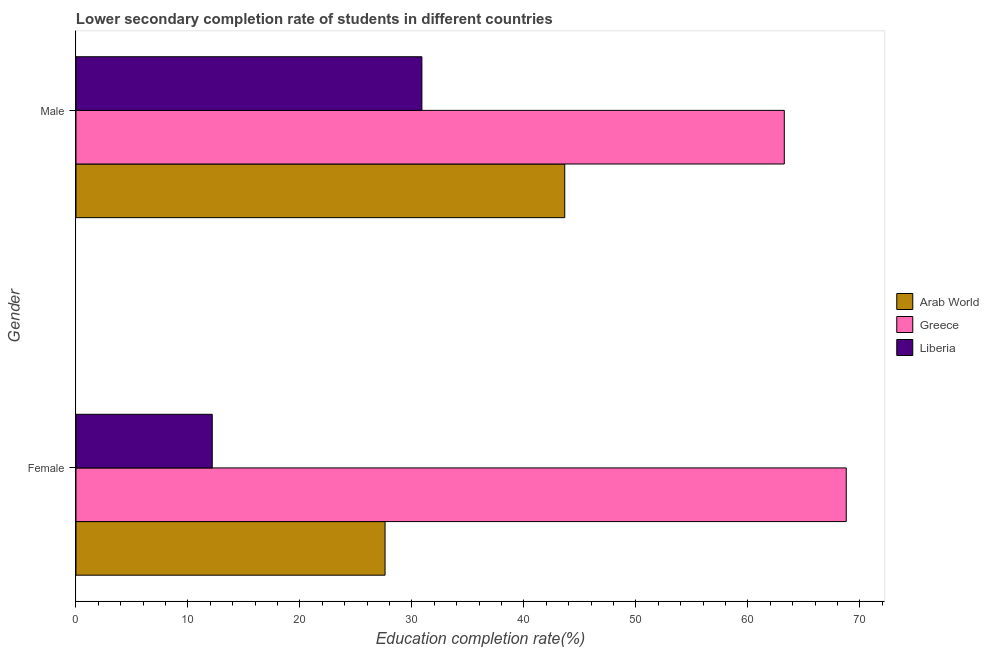Are the number of bars per tick equal to the number of legend labels?
Keep it short and to the point. Yes. What is the education completion rate of female students in Arab World?
Offer a terse response. 27.6. Across all countries, what is the maximum education completion rate of male students?
Your response must be concise. 63.25. Across all countries, what is the minimum education completion rate of male students?
Ensure brevity in your answer.  30.89. In which country was the education completion rate of female students minimum?
Offer a very short reply. Liberia. What is the total education completion rate of male students in the graph?
Offer a very short reply. 137.79. What is the difference between the education completion rate of male students in Arab World and that in Liberia?
Provide a succinct answer. 12.76. What is the difference between the education completion rate of female students in Liberia and the education completion rate of male students in Greece?
Ensure brevity in your answer.  -51.08. What is the average education completion rate of male students per country?
Your answer should be compact. 45.93. What is the difference between the education completion rate of male students and education completion rate of female students in Greece?
Your answer should be very brief. -5.53. In how many countries, is the education completion rate of female students greater than 14 %?
Ensure brevity in your answer.  2. What is the ratio of the education completion rate of male students in Greece to that in Arab World?
Your answer should be compact. 1.45. Is the education completion rate of male students in Arab World less than that in Liberia?
Your answer should be compact. No. In how many countries, is the education completion rate of male students greater than the average education completion rate of male students taken over all countries?
Keep it short and to the point. 1. What does the 1st bar from the top in Female represents?
Provide a succinct answer. Liberia. What does the 2nd bar from the bottom in Male represents?
Your answer should be very brief. Greece. Are all the bars in the graph horizontal?
Give a very brief answer. Yes. What is the difference between two consecutive major ticks on the X-axis?
Your answer should be very brief. 10. Are the values on the major ticks of X-axis written in scientific E-notation?
Your response must be concise. No. How many legend labels are there?
Ensure brevity in your answer.  3. What is the title of the graph?
Keep it short and to the point. Lower secondary completion rate of students in different countries. Does "Turks and Caicos Islands" appear as one of the legend labels in the graph?
Provide a short and direct response. No. What is the label or title of the X-axis?
Offer a very short reply. Education completion rate(%). What is the Education completion rate(%) in Arab World in Female?
Make the answer very short. 27.6. What is the Education completion rate(%) in Greece in Female?
Provide a succinct answer. 68.78. What is the Education completion rate(%) in Liberia in Female?
Your response must be concise. 12.17. What is the Education completion rate(%) of Arab World in Male?
Ensure brevity in your answer.  43.65. What is the Education completion rate(%) of Greece in Male?
Keep it short and to the point. 63.25. What is the Education completion rate(%) of Liberia in Male?
Make the answer very short. 30.89. Across all Gender, what is the maximum Education completion rate(%) of Arab World?
Your answer should be very brief. 43.65. Across all Gender, what is the maximum Education completion rate(%) of Greece?
Offer a terse response. 68.78. Across all Gender, what is the maximum Education completion rate(%) of Liberia?
Give a very brief answer. 30.89. Across all Gender, what is the minimum Education completion rate(%) in Arab World?
Your response must be concise. 27.6. Across all Gender, what is the minimum Education completion rate(%) of Greece?
Your answer should be compact. 63.25. Across all Gender, what is the minimum Education completion rate(%) in Liberia?
Your answer should be compact. 12.17. What is the total Education completion rate(%) in Arab World in the graph?
Offer a very short reply. 71.25. What is the total Education completion rate(%) in Greece in the graph?
Give a very brief answer. 132.04. What is the total Education completion rate(%) of Liberia in the graph?
Offer a terse response. 43.06. What is the difference between the Education completion rate(%) of Arab World in Female and that in Male?
Provide a short and direct response. -16.05. What is the difference between the Education completion rate(%) of Greece in Female and that in Male?
Provide a short and direct response. 5.53. What is the difference between the Education completion rate(%) of Liberia in Female and that in Male?
Offer a terse response. -18.72. What is the difference between the Education completion rate(%) in Arab World in Female and the Education completion rate(%) in Greece in Male?
Your answer should be very brief. -35.65. What is the difference between the Education completion rate(%) in Arab World in Female and the Education completion rate(%) in Liberia in Male?
Provide a short and direct response. -3.29. What is the difference between the Education completion rate(%) in Greece in Female and the Education completion rate(%) in Liberia in Male?
Ensure brevity in your answer.  37.89. What is the average Education completion rate(%) in Arab World per Gender?
Offer a terse response. 35.62. What is the average Education completion rate(%) in Greece per Gender?
Keep it short and to the point. 66.02. What is the average Education completion rate(%) of Liberia per Gender?
Your answer should be compact. 21.53. What is the difference between the Education completion rate(%) in Arab World and Education completion rate(%) in Greece in Female?
Your answer should be very brief. -41.18. What is the difference between the Education completion rate(%) of Arab World and Education completion rate(%) of Liberia in Female?
Keep it short and to the point. 15.43. What is the difference between the Education completion rate(%) of Greece and Education completion rate(%) of Liberia in Female?
Keep it short and to the point. 56.62. What is the difference between the Education completion rate(%) in Arab World and Education completion rate(%) in Greece in Male?
Offer a terse response. -19.61. What is the difference between the Education completion rate(%) in Arab World and Education completion rate(%) in Liberia in Male?
Give a very brief answer. 12.76. What is the difference between the Education completion rate(%) in Greece and Education completion rate(%) in Liberia in Male?
Your answer should be compact. 32.36. What is the ratio of the Education completion rate(%) of Arab World in Female to that in Male?
Your answer should be very brief. 0.63. What is the ratio of the Education completion rate(%) in Greece in Female to that in Male?
Make the answer very short. 1.09. What is the ratio of the Education completion rate(%) in Liberia in Female to that in Male?
Offer a very short reply. 0.39. What is the difference between the highest and the second highest Education completion rate(%) in Arab World?
Ensure brevity in your answer.  16.05. What is the difference between the highest and the second highest Education completion rate(%) of Greece?
Ensure brevity in your answer.  5.53. What is the difference between the highest and the second highest Education completion rate(%) of Liberia?
Give a very brief answer. 18.72. What is the difference between the highest and the lowest Education completion rate(%) in Arab World?
Keep it short and to the point. 16.05. What is the difference between the highest and the lowest Education completion rate(%) in Greece?
Your answer should be compact. 5.53. What is the difference between the highest and the lowest Education completion rate(%) of Liberia?
Provide a succinct answer. 18.72. 